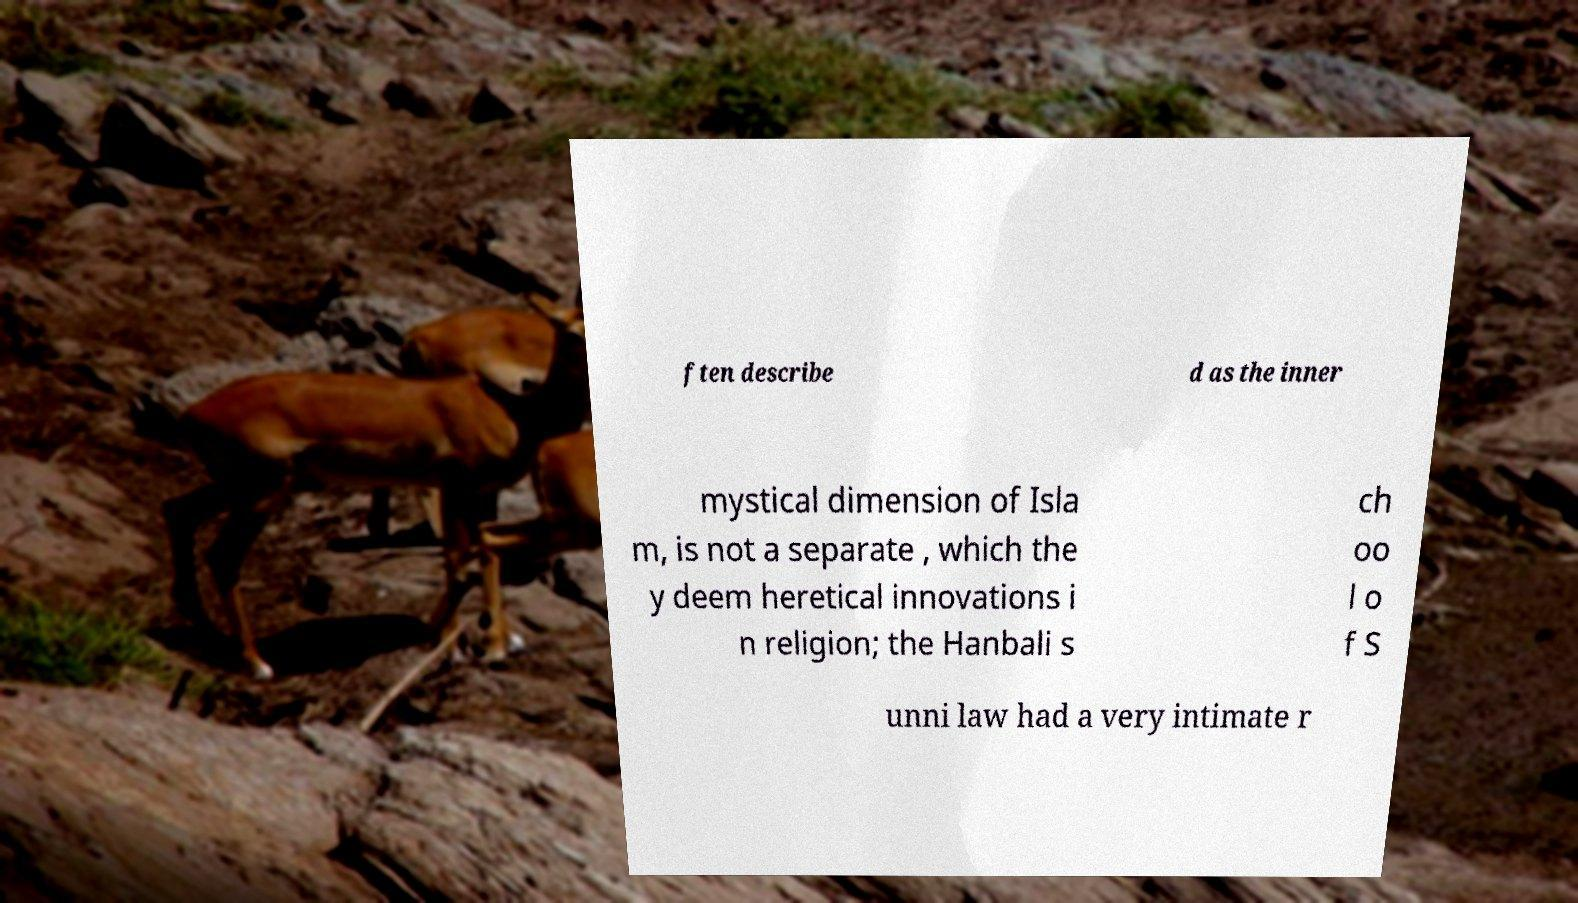Can you accurately transcribe the text from the provided image for me? ften describe d as the inner mystical dimension of Isla m, is not a separate , which the y deem heretical innovations i n religion; the Hanbali s ch oo l o f S unni law had a very intimate r 